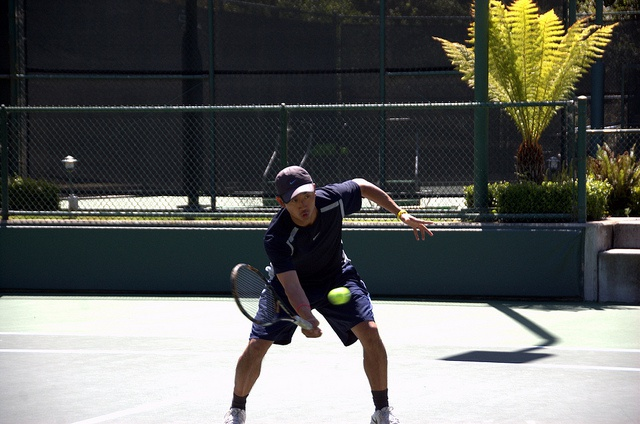Describe the objects in this image and their specific colors. I can see people in black, maroon, and gray tones, tennis racket in black, gray, and ivory tones, bench in black, white, and darkblue tones, and sports ball in black, olive, ivory, and darkgreen tones in this image. 